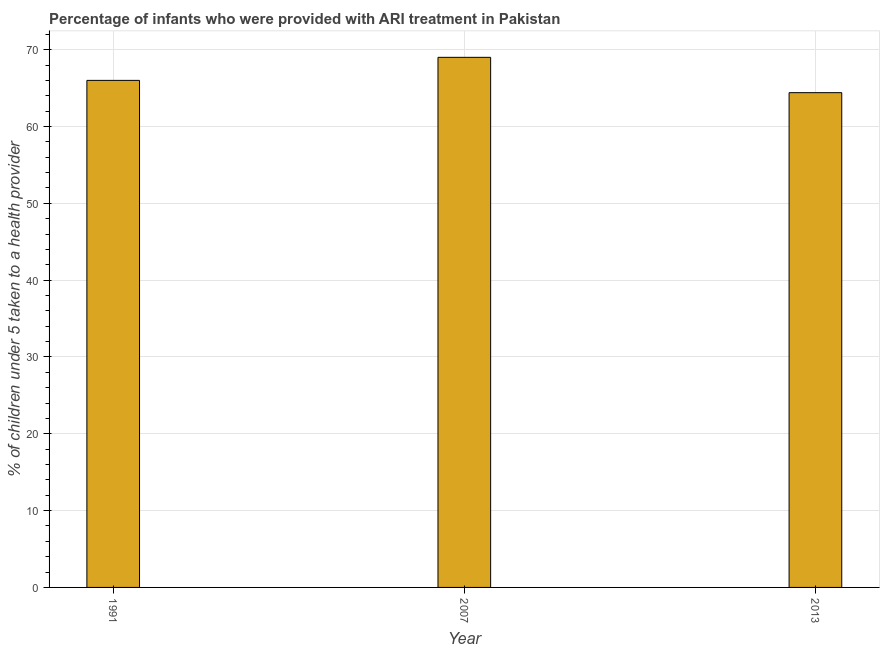Does the graph contain any zero values?
Keep it short and to the point. No. What is the title of the graph?
Provide a short and direct response. Percentage of infants who were provided with ARI treatment in Pakistan. What is the label or title of the Y-axis?
Give a very brief answer. % of children under 5 taken to a health provider. What is the percentage of children who were provided with ari treatment in 2013?
Offer a terse response. 64.4. Across all years, what is the minimum percentage of children who were provided with ari treatment?
Ensure brevity in your answer.  64.4. In which year was the percentage of children who were provided with ari treatment minimum?
Provide a short and direct response. 2013. What is the sum of the percentage of children who were provided with ari treatment?
Offer a very short reply. 199.4. What is the difference between the percentage of children who were provided with ari treatment in 2007 and 2013?
Your response must be concise. 4.6. What is the average percentage of children who were provided with ari treatment per year?
Make the answer very short. 66.47. Do a majority of the years between 2007 and 2013 (inclusive) have percentage of children who were provided with ari treatment greater than 56 %?
Give a very brief answer. Yes. What is the ratio of the percentage of children who were provided with ari treatment in 1991 to that in 2013?
Offer a very short reply. 1.02. Is the percentage of children who were provided with ari treatment in 1991 less than that in 2007?
Offer a very short reply. Yes. What is the difference between the highest and the second highest percentage of children who were provided with ari treatment?
Your response must be concise. 3. Is the sum of the percentage of children who were provided with ari treatment in 1991 and 2007 greater than the maximum percentage of children who were provided with ari treatment across all years?
Your answer should be very brief. Yes. How many bars are there?
Keep it short and to the point. 3. How many years are there in the graph?
Ensure brevity in your answer.  3. What is the difference between two consecutive major ticks on the Y-axis?
Give a very brief answer. 10. What is the % of children under 5 taken to a health provider of 2007?
Your answer should be compact. 69. What is the % of children under 5 taken to a health provider in 2013?
Offer a terse response. 64.4. What is the difference between the % of children under 5 taken to a health provider in 1991 and 2007?
Make the answer very short. -3. What is the difference between the % of children under 5 taken to a health provider in 2007 and 2013?
Provide a short and direct response. 4.6. What is the ratio of the % of children under 5 taken to a health provider in 2007 to that in 2013?
Your answer should be very brief. 1.07. 